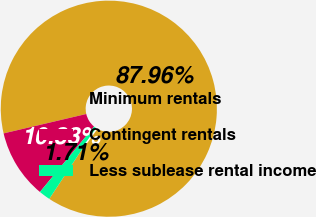Convert chart to OTSL. <chart><loc_0><loc_0><loc_500><loc_500><pie_chart><fcel>Minimum rentals<fcel>Contingent rentals<fcel>Less sublease rental income<nl><fcel>87.96%<fcel>10.33%<fcel>1.71%<nl></chart> 